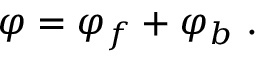Convert formula to latex. <formula><loc_0><loc_0><loc_500><loc_500>\varphi = \varphi _ { f } + \varphi _ { b } \ .</formula> 